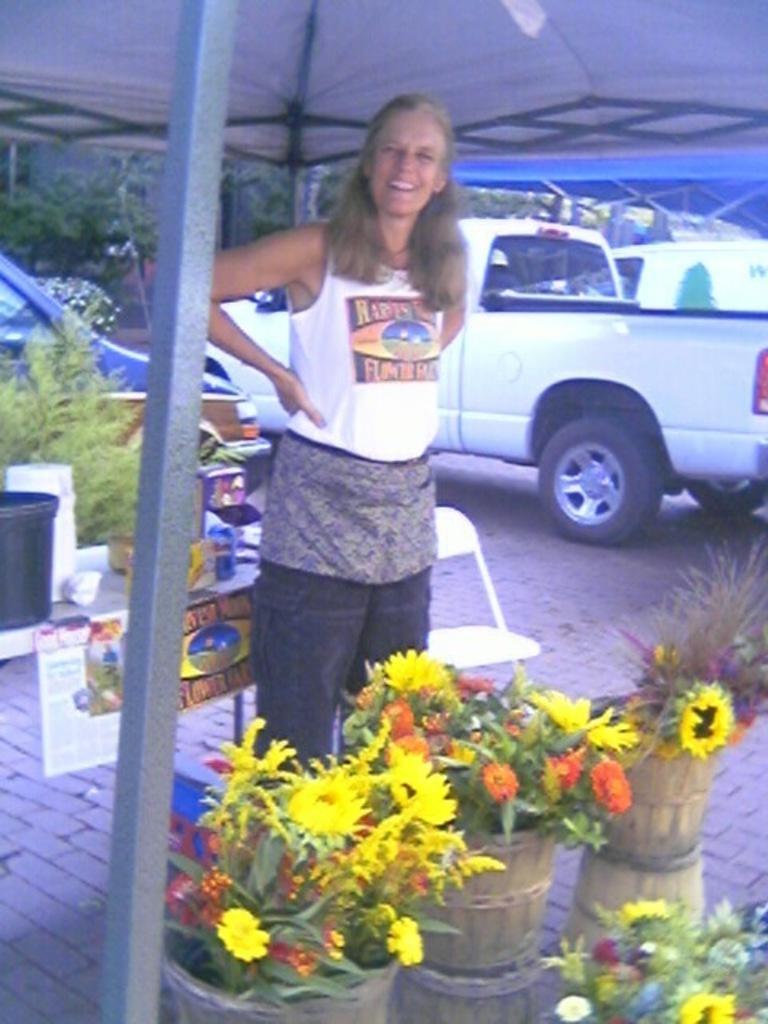In one or two sentences, can you explain what this image depicts? In this image we can see a lady. There are many plants and plant pots in the image. There are flowers to the plants. There are many objects on the table in the image.. There is a chair in the image. There is a tent in the image. 